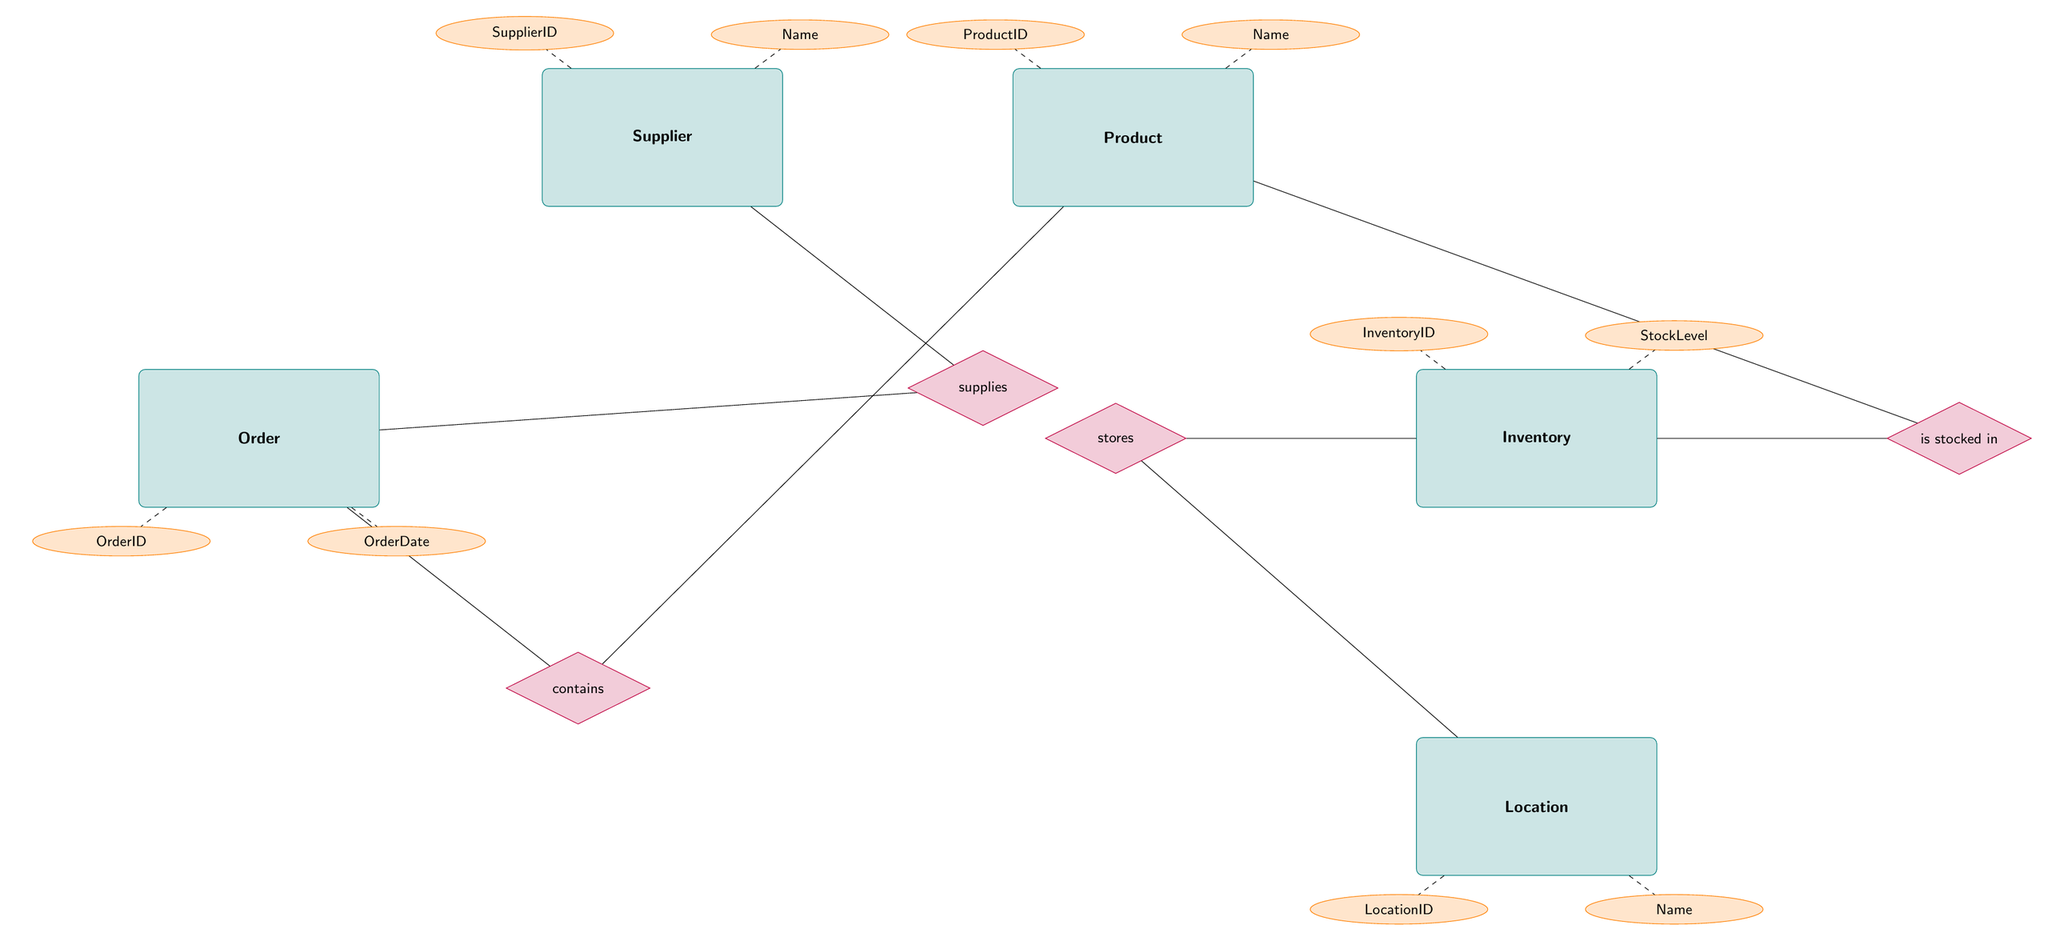What is the relationship between Supplier and Order? In the diagram, there is a labeled relationship connecting the Supplier entity to the Order entity. It is indicated as "supplies," meaning each Supplier can supply multiple Orders.
Answer: supplies How many attributes does the Product entity have? By examining the diagram, the Product entity has a total of five attributes listed: ProductID, Name, Description, UnitPrice, and Category.
Answer: 5 What is the primary key for the Inventory entity? The Inventory entity has the attribute "InventoryID" marked, which serves as its primary key as indicated by the typical conventions of ER diagrams.
Answer: InventoryID What is the relationship type between Order and Product? The arrow connecting the Order and Product entities through the OrderDetails indicates a Many-to-Many relationship, described as "contains," meaning multiple Orders can contain multiple Products.
Answer: Many-to-Many Which entity stores the Inventory? The diagram shows a One-to-Many relationship from the Location entity to the Inventory entity, meaning that each Location can store multiple Inventory items. The relationship is labeled "stores."
Answer: Location What are the StockLevel and ReorderLevel attributes? In the Inventory entity, the attributes listed include StockLevel and ReorderLevel, which are critical for managing inventory levels. The StockLevel is the current quantity available, while the ReorderLevel indicates when new stock should be ordered.
Answer: StockLevel, ReorderLevel How many relationships are displayed in the diagram? By counting all the relationship lines connecting the various entities, there are a total of four relationships labeled in the diagram.
Answer: 4 Which entity is connected to both Inventory and Location? The Inventory entity is connected to both the Location and Product entities through their respective relationships. The Location entity has a relationship indicated by "stores," which shows where Inventory is kept.
Answer: Inventory What is the total number of entities in this diagram? The diagram contains a total of six entities: Supplier, Product, Inventory, Order, OrderDetails, and Location.
Answer: 6 